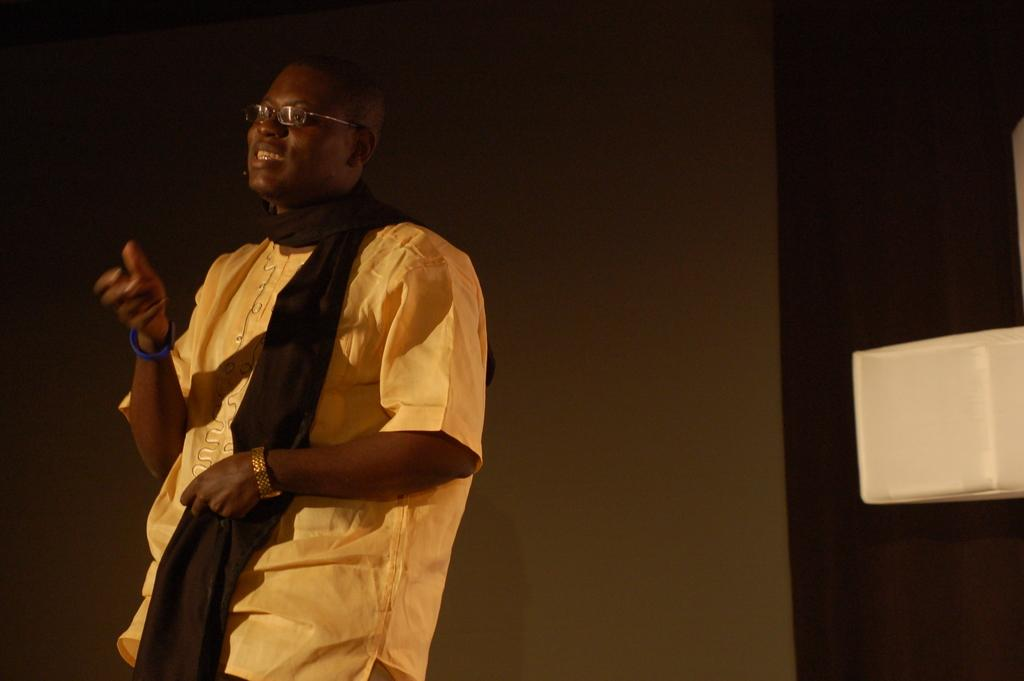What is the main subject of the image? There is a person in the center of the image. What is the person wearing in the image? The person is wearing a scarf. What can be seen in the background of the image? There is a wall in the background of the image. What type of blood is visible on the person's scarf in the image? There is no blood visible on the person's scarf in the image. What role does the person play in society in the image? The image does not provide any information about the person's role in society. 